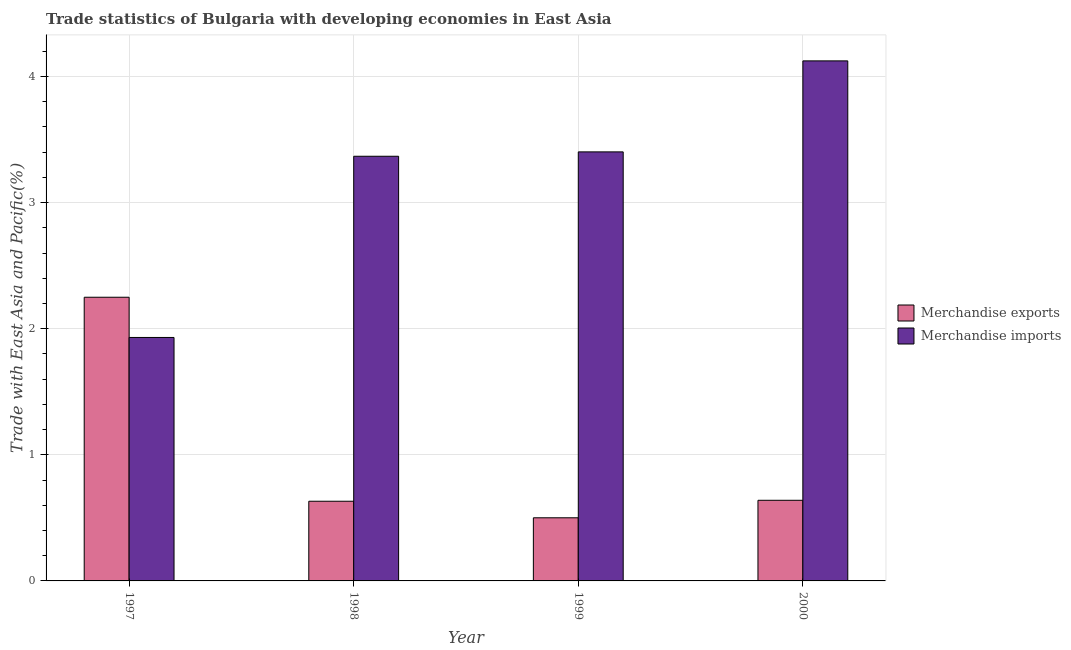How many different coloured bars are there?
Give a very brief answer. 2. Are the number of bars per tick equal to the number of legend labels?
Ensure brevity in your answer.  Yes. Are the number of bars on each tick of the X-axis equal?
Offer a terse response. Yes. What is the label of the 1st group of bars from the left?
Make the answer very short. 1997. What is the merchandise imports in 1999?
Provide a short and direct response. 3.4. Across all years, what is the maximum merchandise imports?
Make the answer very short. 4.12. Across all years, what is the minimum merchandise exports?
Ensure brevity in your answer.  0.5. What is the total merchandise exports in the graph?
Give a very brief answer. 4.02. What is the difference between the merchandise imports in 1998 and that in 1999?
Offer a very short reply. -0.03. What is the difference between the merchandise exports in 1999 and the merchandise imports in 1998?
Provide a short and direct response. -0.13. What is the average merchandise exports per year?
Ensure brevity in your answer.  1.01. In the year 2000, what is the difference between the merchandise exports and merchandise imports?
Provide a short and direct response. 0. What is the ratio of the merchandise exports in 1997 to that in 1998?
Provide a succinct answer. 3.56. Is the merchandise imports in 1998 less than that in 1999?
Keep it short and to the point. Yes. What is the difference between the highest and the second highest merchandise exports?
Offer a very short reply. 1.61. What is the difference between the highest and the lowest merchandise imports?
Give a very brief answer. 2.19. What does the 1st bar from the left in 1998 represents?
Your answer should be very brief. Merchandise exports. What does the 1st bar from the right in 2000 represents?
Keep it short and to the point. Merchandise imports. How many bars are there?
Make the answer very short. 8. Are all the bars in the graph horizontal?
Make the answer very short. No. How many years are there in the graph?
Provide a short and direct response. 4. What is the difference between two consecutive major ticks on the Y-axis?
Give a very brief answer. 1. Are the values on the major ticks of Y-axis written in scientific E-notation?
Give a very brief answer. No. How are the legend labels stacked?
Provide a short and direct response. Vertical. What is the title of the graph?
Your answer should be compact. Trade statistics of Bulgaria with developing economies in East Asia. Does "Broad money growth" appear as one of the legend labels in the graph?
Make the answer very short. No. What is the label or title of the Y-axis?
Make the answer very short. Trade with East Asia and Pacific(%). What is the Trade with East Asia and Pacific(%) of Merchandise exports in 1997?
Your answer should be compact. 2.25. What is the Trade with East Asia and Pacific(%) in Merchandise imports in 1997?
Your answer should be compact. 1.93. What is the Trade with East Asia and Pacific(%) of Merchandise exports in 1998?
Ensure brevity in your answer.  0.63. What is the Trade with East Asia and Pacific(%) in Merchandise imports in 1998?
Provide a succinct answer. 3.37. What is the Trade with East Asia and Pacific(%) in Merchandise exports in 1999?
Offer a very short reply. 0.5. What is the Trade with East Asia and Pacific(%) in Merchandise imports in 1999?
Provide a short and direct response. 3.4. What is the Trade with East Asia and Pacific(%) in Merchandise exports in 2000?
Provide a succinct answer. 0.64. What is the Trade with East Asia and Pacific(%) of Merchandise imports in 2000?
Give a very brief answer. 4.12. Across all years, what is the maximum Trade with East Asia and Pacific(%) in Merchandise exports?
Your answer should be compact. 2.25. Across all years, what is the maximum Trade with East Asia and Pacific(%) in Merchandise imports?
Your response must be concise. 4.12. Across all years, what is the minimum Trade with East Asia and Pacific(%) in Merchandise exports?
Your answer should be very brief. 0.5. Across all years, what is the minimum Trade with East Asia and Pacific(%) in Merchandise imports?
Ensure brevity in your answer.  1.93. What is the total Trade with East Asia and Pacific(%) of Merchandise exports in the graph?
Offer a very short reply. 4.02. What is the total Trade with East Asia and Pacific(%) in Merchandise imports in the graph?
Your response must be concise. 12.82. What is the difference between the Trade with East Asia and Pacific(%) in Merchandise exports in 1997 and that in 1998?
Ensure brevity in your answer.  1.62. What is the difference between the Trade with East Asia and Pacific(%) in Merchandise imports in 1997 and that in 1998?
Your answer should be very brief. -1.44. What is the difference between the Trade with East Asia and Pacific(%) in Merchandise exports in 1997 and that in 1999?
Offer a terse response. 1.75. What is the difference between the Trade with East Asia and Pacific(%) in Merchandise imports in 1997 and that in 1999?
Make the answer very short. -1.47. What is the difference between the Trade with East Asia and Pacific(%) of Merchandise exports in 1997 and that in 2000?
Give a very brief answer. 1.61. What is the difference between the Trade with East Asia and Pacific(%) in Merchandise imports in 1997 and that in 2000?
Provide a short and direct response. -2.19. What is the difference between the Trade with East Asia and Pacific(%) in Merchandise exports in 1998 and that in 1999?
Provide a succinct answer. 0.13. What is the difference between the Trade with East Asia and Pacific(%) of Merchandise imports in 1998 and that in 1999?
Offer a terse response. -0.03. What is the difference between the Trade with East Asia and Pacific(%) in Merchandise exports in 1998 and that in 2000?
Ensure brevity in your answer.  -0.01. What is the difference between the Trade with East Asia and Pacific(%) in Merchandise imports in 1998 and that in 2000?
Keep it short and to the point. -0.76. What is the difference between the Trade with East Asia and Pacific(%) of Merchandise exports in 1999 and that in 2000?
Keep it short and to the point. -0.14. What is the difference between the Trade with East Asia and Pacific(%) of Merchandise imports in 1999 and that in 2000?
Keep it short and to the point. -0.72. What is the difference between the Trade with East Asia and Pacific(%) in Merchandise exports in 1997 and the Trade with East Asia and Pacific(%) in Merchandise imports in 1998?
Give a very brief answer. -1.12. What is the difference between the Trade with East Asia and Pacific(%) in Merchandise exports in 1997 and the Trade with East Asia and Pacific(%) in Merchandise imports in 1999?
Ensure brevity in your answer.  -1.15. What is the difference between the Trade with East Asia and Pacific(%) in Merchandise exports in 1997 and the Trade with East Asia and Pacific(%) in Merchandise imports in 2000?
Offer a terse response. -1.87. What is the difference between the Trade with East Asia and Pacific(%) of Merchandise exports in 1998 and the Trade with East Asia and Pacific(%) of Merchandise imports in 1999?
Your answer should be very brief. -2.77. What is the difference between the Trade with East Asia and Pacific(%) of Merchandise exports in 1998 and the Trade with East Asia and Pacific(%) of Merchandise imports in 2000?
Offer a terse response. -3.49. What is the difference between the Trade with East Asia and Pacific(%) of Merchandise exports in 1999 and the Trade with East Asia and Pacific(%) of Merchandise imports in 2000?
Keep it short and to the point. -3.62. What is the average Trade with East Asia and Pacific(%) in Merchandise exports per year?
Offer a terse response. 1.01. What is the average Trade with East Asia and Pacific(%) in Merchandise imports per year?
Give a very brief answer. 3.21. In the year 1997, what is the difference between the Trade with East Asia and Pacific(%) of Merchandise exports and Trade with East Asia and Pacific(%) of Merchandise imports?
Provide a succinct answer. 0.32. In the year 1998, what is the difference between the Trade with East Asia and Pacific(%) in Merchandise exports and Trade with East Asia and Pacific(%) in Merchandise imports?
Offer a terse response. -2.74. In the year 1999, what is the difference between the Trade with East Asia and Pacific(%) in Merchandise exports and Trade with East Asia and Pacific(%) in Merchandise imports?
Offer a terse response. -2.9. In the year 2000, what is the difference between the Trade with East Asia and Pacific(%) of Merchandise exports and Trade with East Asia and Pacific(%) of Merchandise imports?
Ensure brevity in your answer.  -3.48. What is the ratio of the Trade with East Asia and Pacific(%) in Merchandise exports in 1997 to that in 1998?
Your response must be concise. 3.56. What is the ratio of the Trade with East Asia and Pacific(%) in Merchandise imports in 1997 to that in 1998?
Provide a short and direct response. 0.57. What is the ratio of the Trade with East Asia and Pacific(%) of Merchandise exports in 1997 to that in 1999?
Your response must be concise. 4.49. What is the ratio of the Trade with East Asia and Pacific(%) in Merchandise imports in 1997 to that in 1999?
Give a very brief answer. 0.57. What is the ratio of the Trade with East Asia and Pacific(%) in Merchandise exports in 1997 to that in 2000?
Offer a terse response. 3.52. What is the ratio of the Trade with East Asia and Pacific(%) in Merchandise imports in 1997 to that in 2000?
Offer a very short reply. 0.47. What is the ratio of the Trade with East Asia and Pacific(%) in Merchandise exports in 1998 to that in 1999?
Ensure brevity in your answer.  1.26. What is the ratio of the Trade with East Asia and Pacific(%) in Merchandise imports in 1998 to that in 1999?
Keep it short and to the point. 0.99. What is the ratio of the Trade with East Asia and Pacific(%) in Merchandise imports in 1998 to that in 2000?
Provide a short and direct response. 0.82. What is the ratio of the Trade with East Asia and Pacific(%) in Merchandise exports in 1999 to that in 2000?
Make the answer very short. 0.78. What is the ratio of the Trade with East Asia and Pacific(%) of Merchandise imports in 1999 to that in 2000?
Offer a terse response. 0.82. What is the difference between the highest and the second highest Trade with East Asia and Pacific(%) of Merchandise exports?
Your answer should be very brief. 1.61. What is the difference between the highest and the second highest Trade with East Asia and Pacific(%) in Merchandise imports?
Offer a terse response. 0.72. What is the difference between the highest and the lowest Trade with East Asia and Pacific(%) of Merchandise exports?
Your response must be concise. 1.75. What is the difference between the highest and the lowest Trade with East Asia and Pacific(%) in Merchandise imports?
Provide a succinct answer. 2.19. 